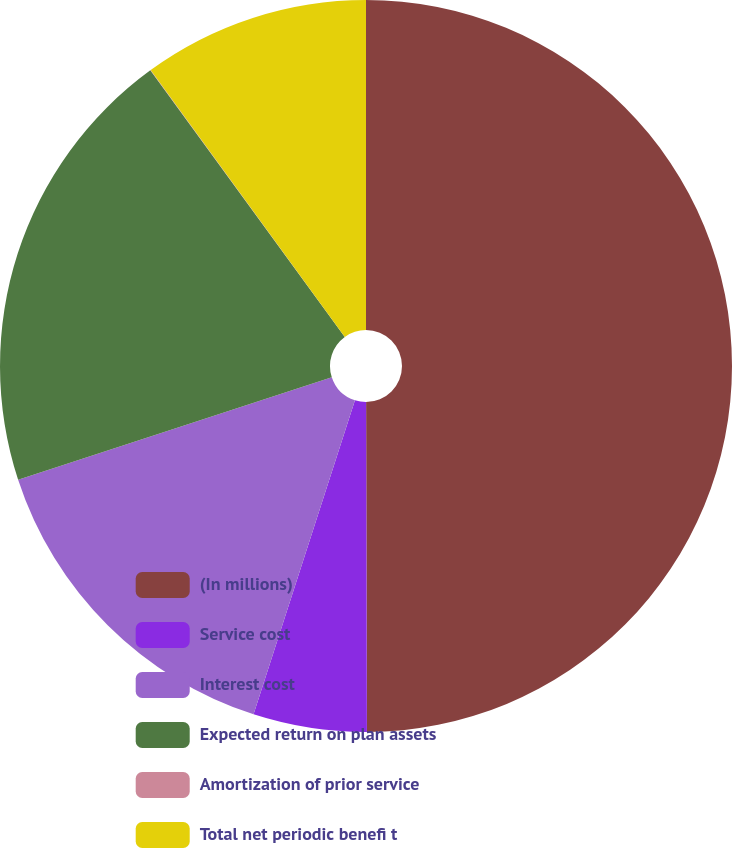<chart> <loc_0><loc_0><loc_500><loc_500><pie_chart><fcel>(In millions)<fcel>Service cost<fcel>Interest cost<fcel>Expected return on plan assets<fcel>Amortization of prior service<fcel>Total net periodic benefi t<nl><fcel>49.96%<fcel>5.01%<fcel>15.0%<fcel>20.0%<fcel>0.02%<fcel>10.01%<nl></chart> 